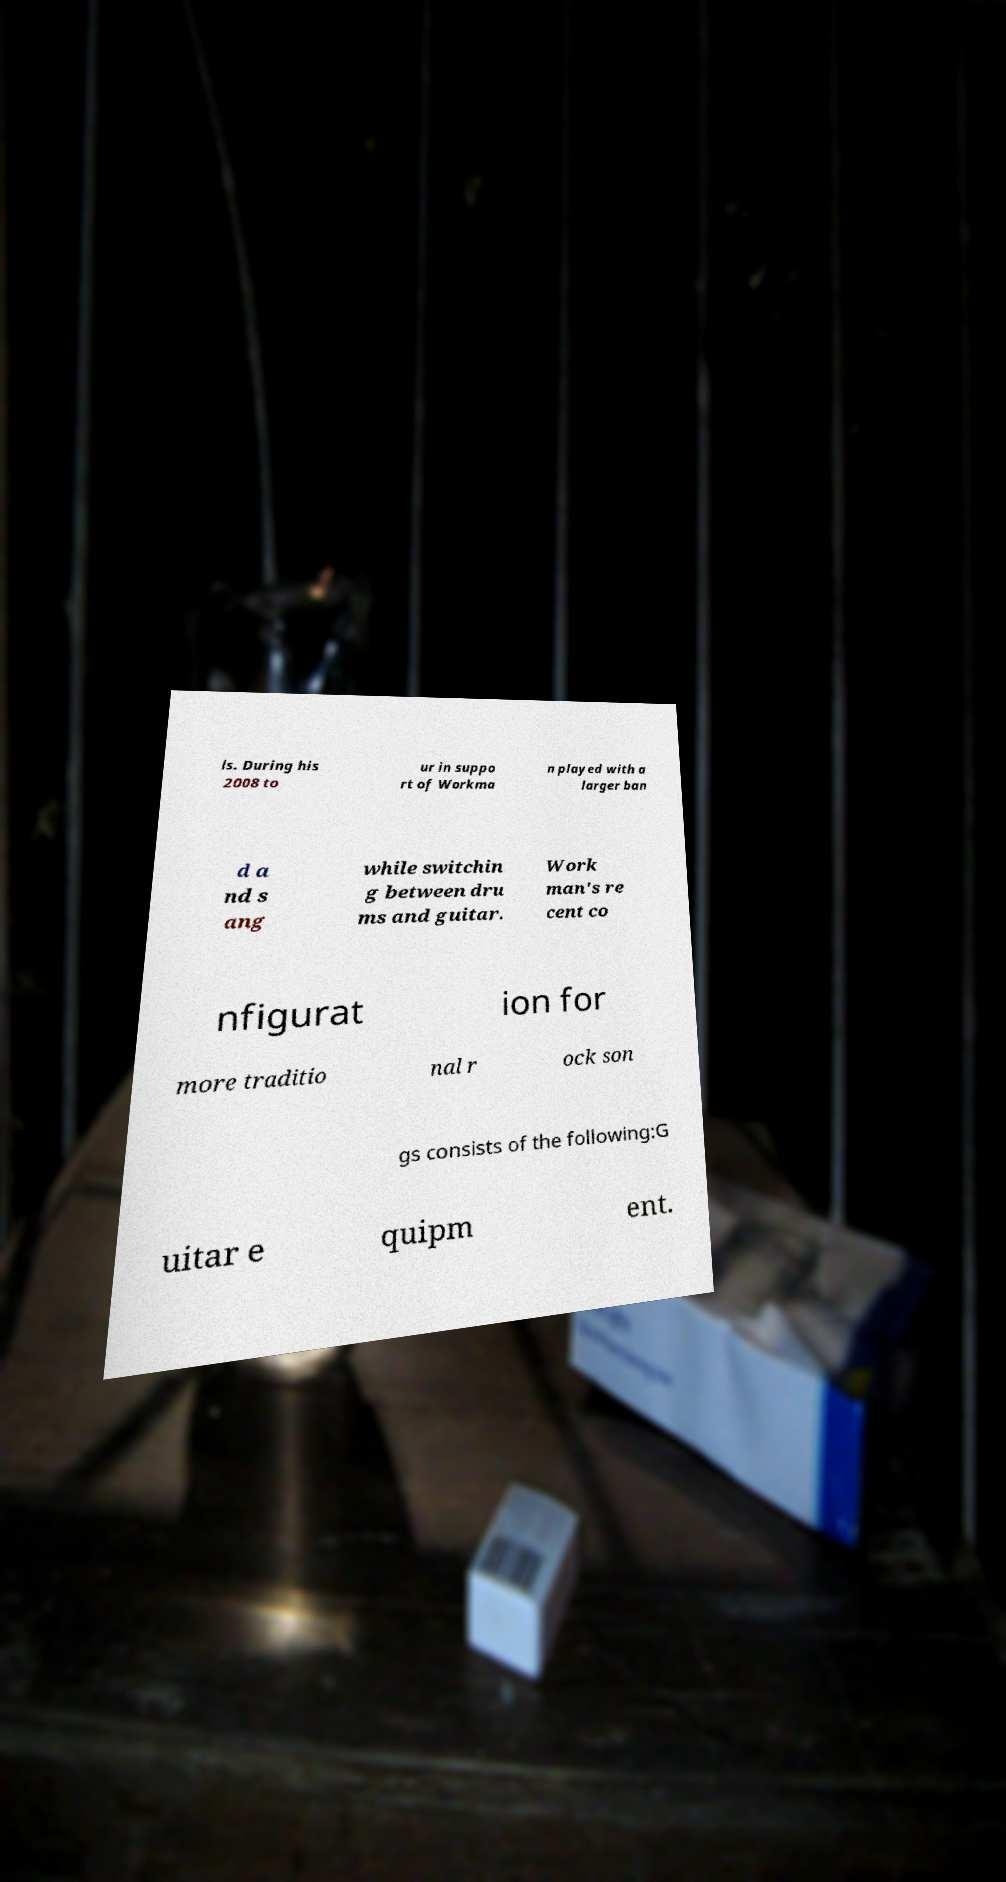For documentation purposes, I need the text within this image transcribed. Could you provide that? ls. During his 2008 to ur in suppo rt of Workma n played with a larger ban d a nd s ang while switchin g between dru ms and guitar. Work man's re cent co nfigurat ion for more traditio nal r ock son gs consists of the following:G uitar e quipm ent. 